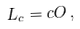<formula> <loc_0><loc_0><loc_500><loc_500>L _ { c } = c O \, ,</formula> 